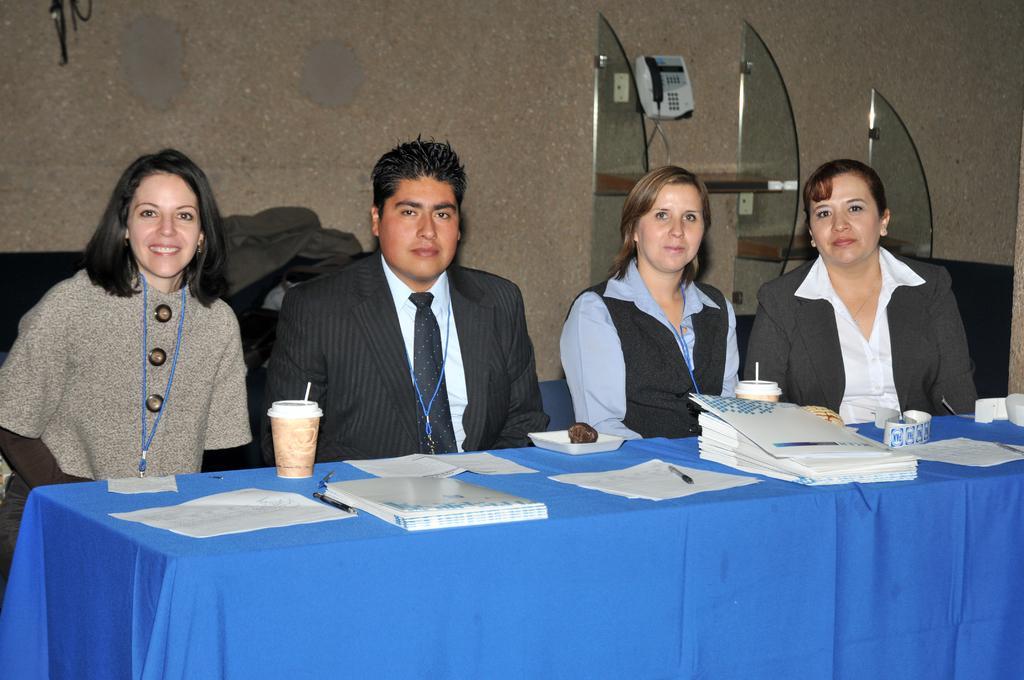Please provide a concise description of this image. In this image in the center there is a table which is covered with a blue colour cloth and on the table there are papers, pens, glasses behind the table there are persons sitting and there is a woman smiling. In the background there is a telephone on the wall and there are shelves and there are objects which are black and grey in colour. 